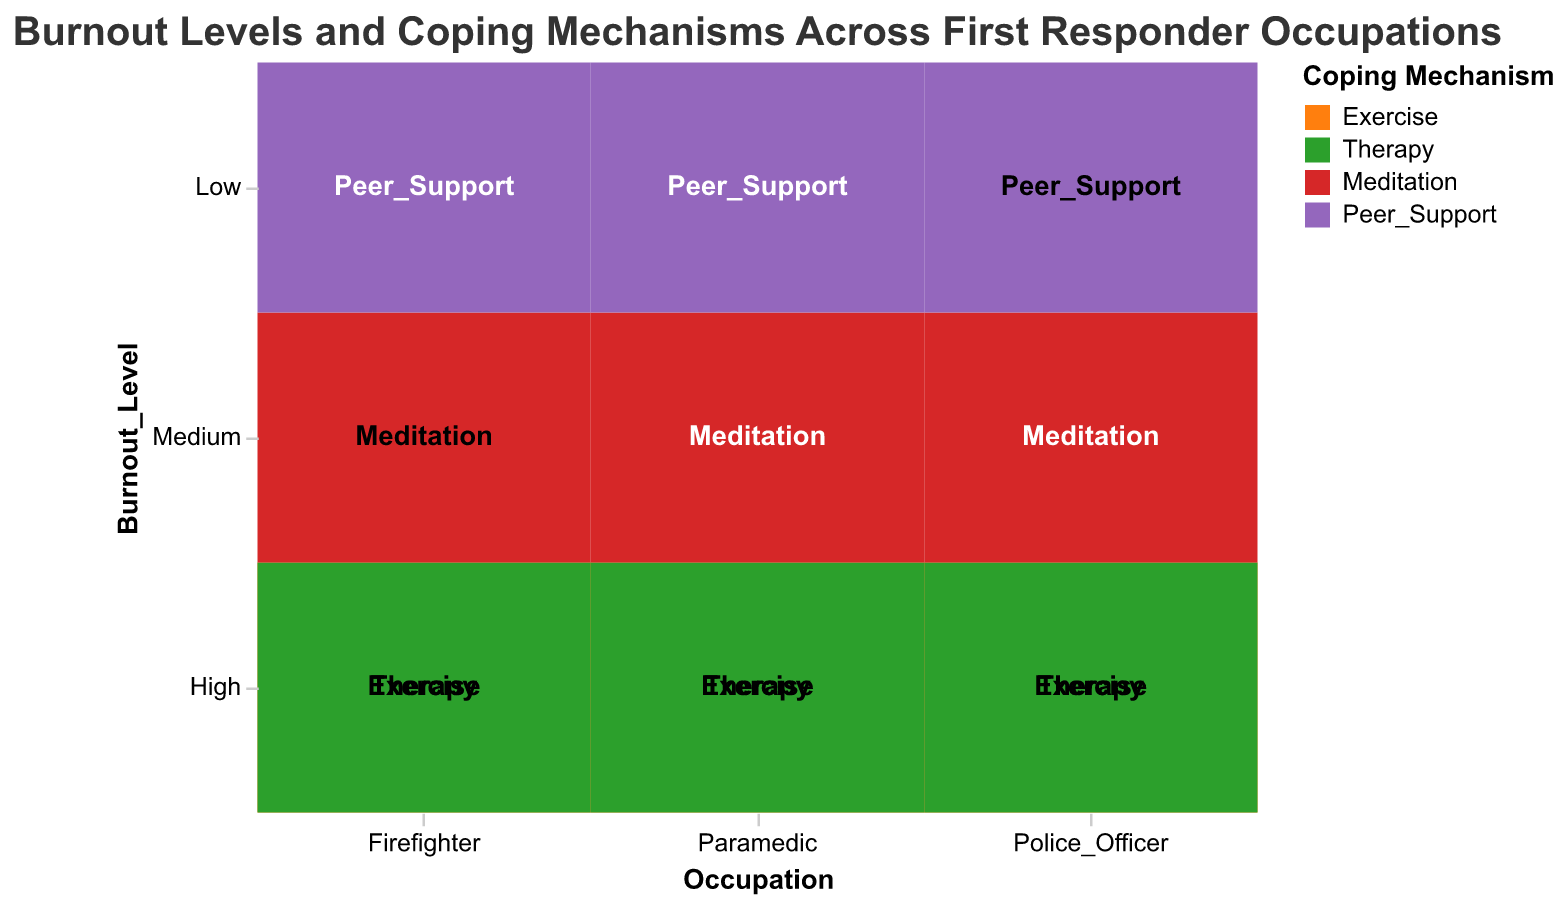What is the title of the plot? The title is displayed at the top and provides an overview of what the plot is about.
Answer: Burnout Levels and Coping Mechanisms Across First Responder Occupations Which coping mechanism is used most by police officers at high burnout levels? Locate the cells corresponding to police officers with high burnout levels and observe the color and label.
Answer: Exercise How many paramedics with medium burnout levels use meditation as a coping mechanism? Identify the cell that corresponds to paramedics with medium burnout levels and check the frequency count for meditation.
Answer: 25 Which occupation has the highest frequency of individuals with low burnout levels using peer support? Compare the frequencies of peer support usage across different occupations at low burnout levels.
Answer: Police Officer What is the total frequency of firefighters with high burnout levels using any coping mechanism? Add the frequencies of all coping mechanisms for firefighters with high burnout levels.
Answer: 75 Are there more police officers or paramedics with a high burnout level using therapy? Compare the frequencies for police officers and paramedics with high burnout levels using therapy.
Answer: Police Officers Which coping mechanism has the lowest frequency among paramedics, regardless of burnout level? Identify the coping mechanism used least frequently by paramedics by comparing frequencies.
Answer: Peer Support What is the combined frequency of all coping mechanisms used by paramedics with high burnout levels? Add the frequencies of all coping mechanisms for paramedics with high burnout levels.
Answer: 75 By how much does the usage of exercise differ between firefighters and police officers with high burnout levels? Subtract the frequency of exercise used by firefighters from the frequency used by police officers at high burnout levels.
Answer: 10 Which coping mechanism is least used by firefighters with medium burnout levels? Observe the coping mechanisms for firefighters with medium burnout levels and note the one with the lowest frequency.
Answer: Meditation 